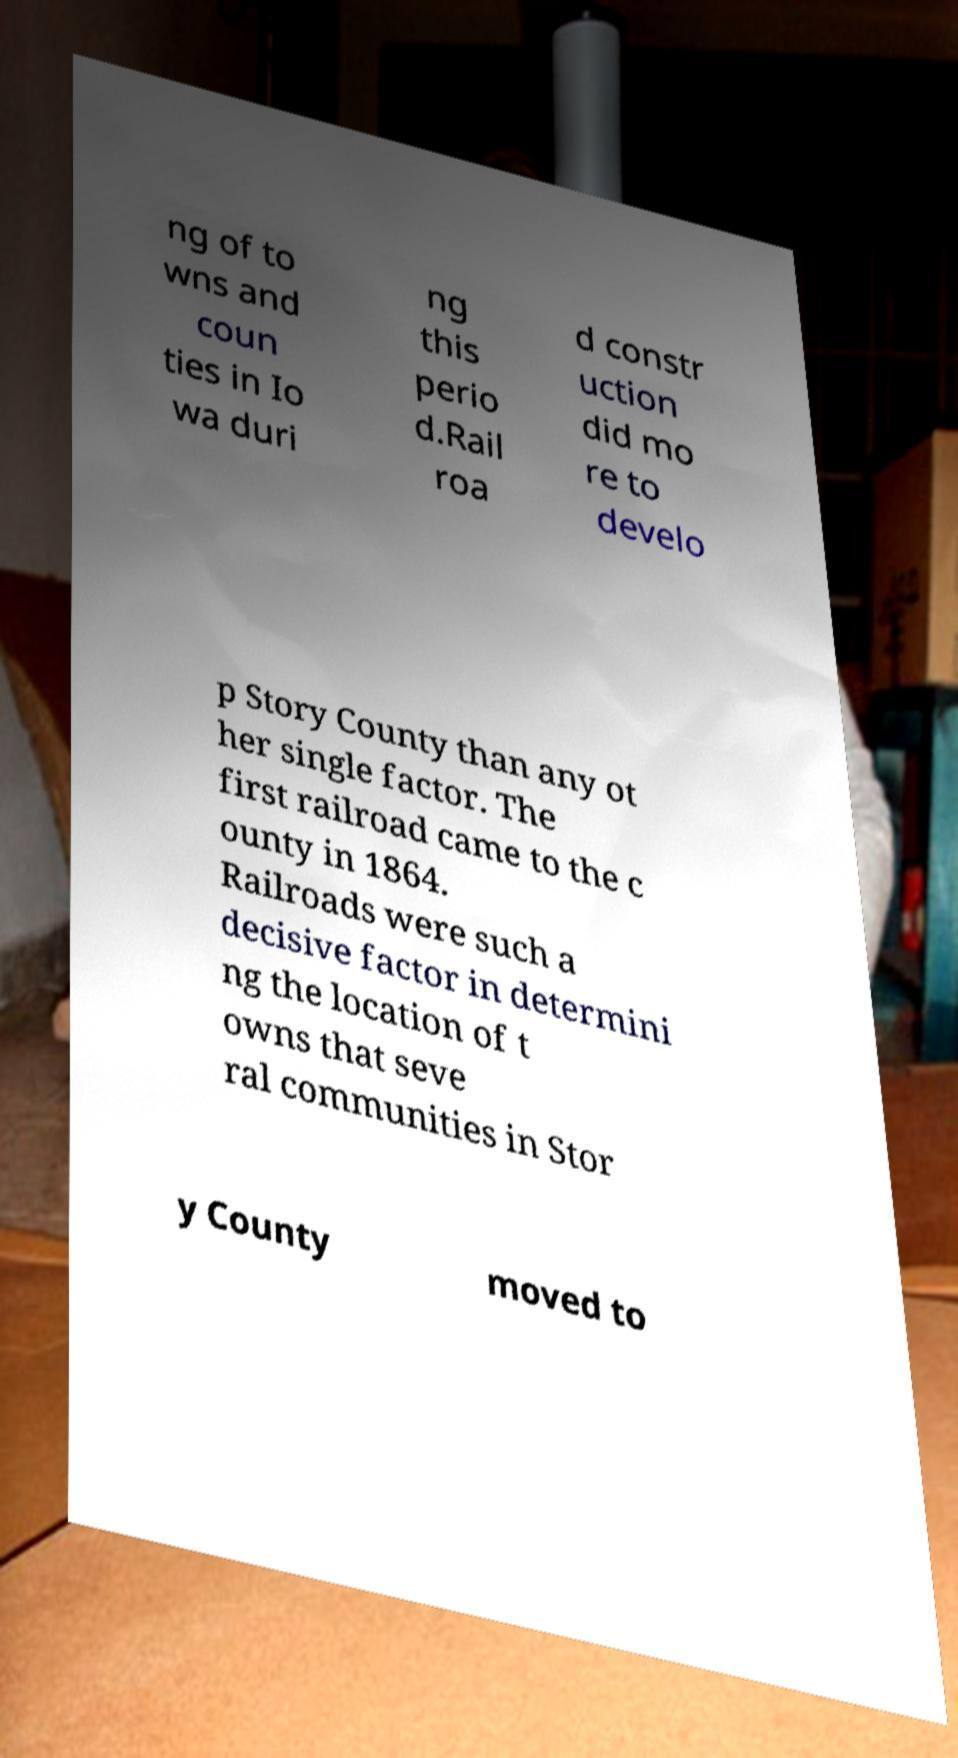For documentation purposes, I need the text within this image transcribed. Could you provide that? ng of to wns and coun ties in Io wa duri ng this perio d.Rail roa d constr uction did mo re to develo p Story County than any ot her single factor. The first railroad came to the c ounty in 1864. Railroads were such a decisive factor in determini ng the location of t owns that seve ral communities in Stor y County moved to 